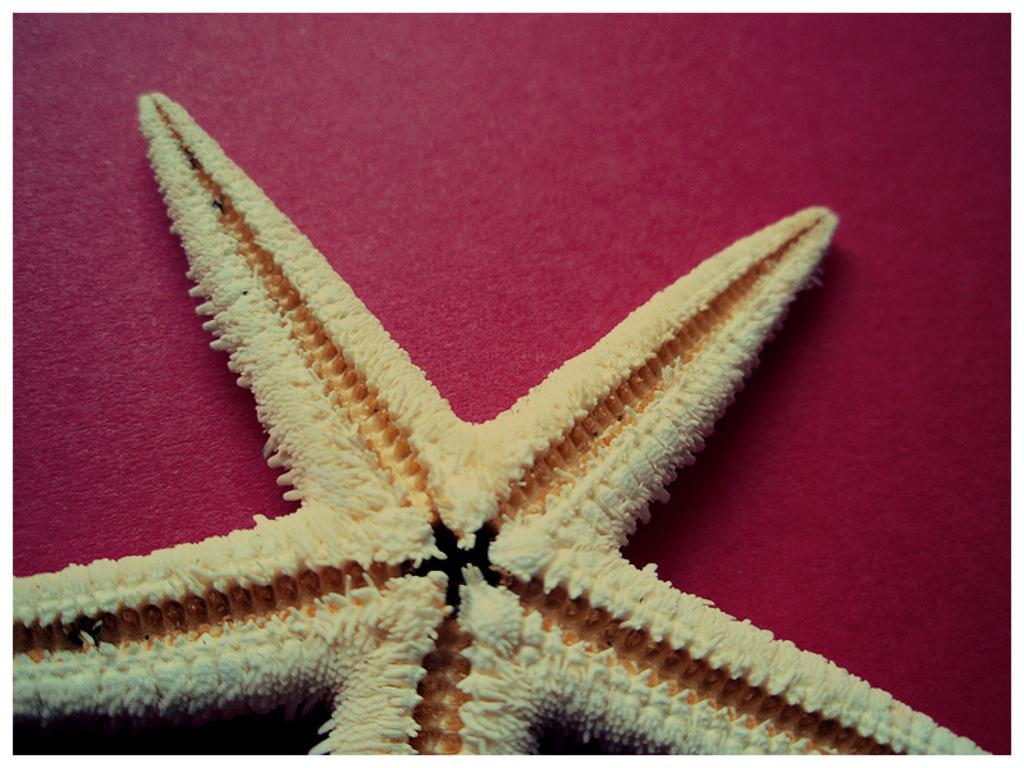Could you give a brief overview of what you see in this image? In this image I can see a starfish on a red color surface. 